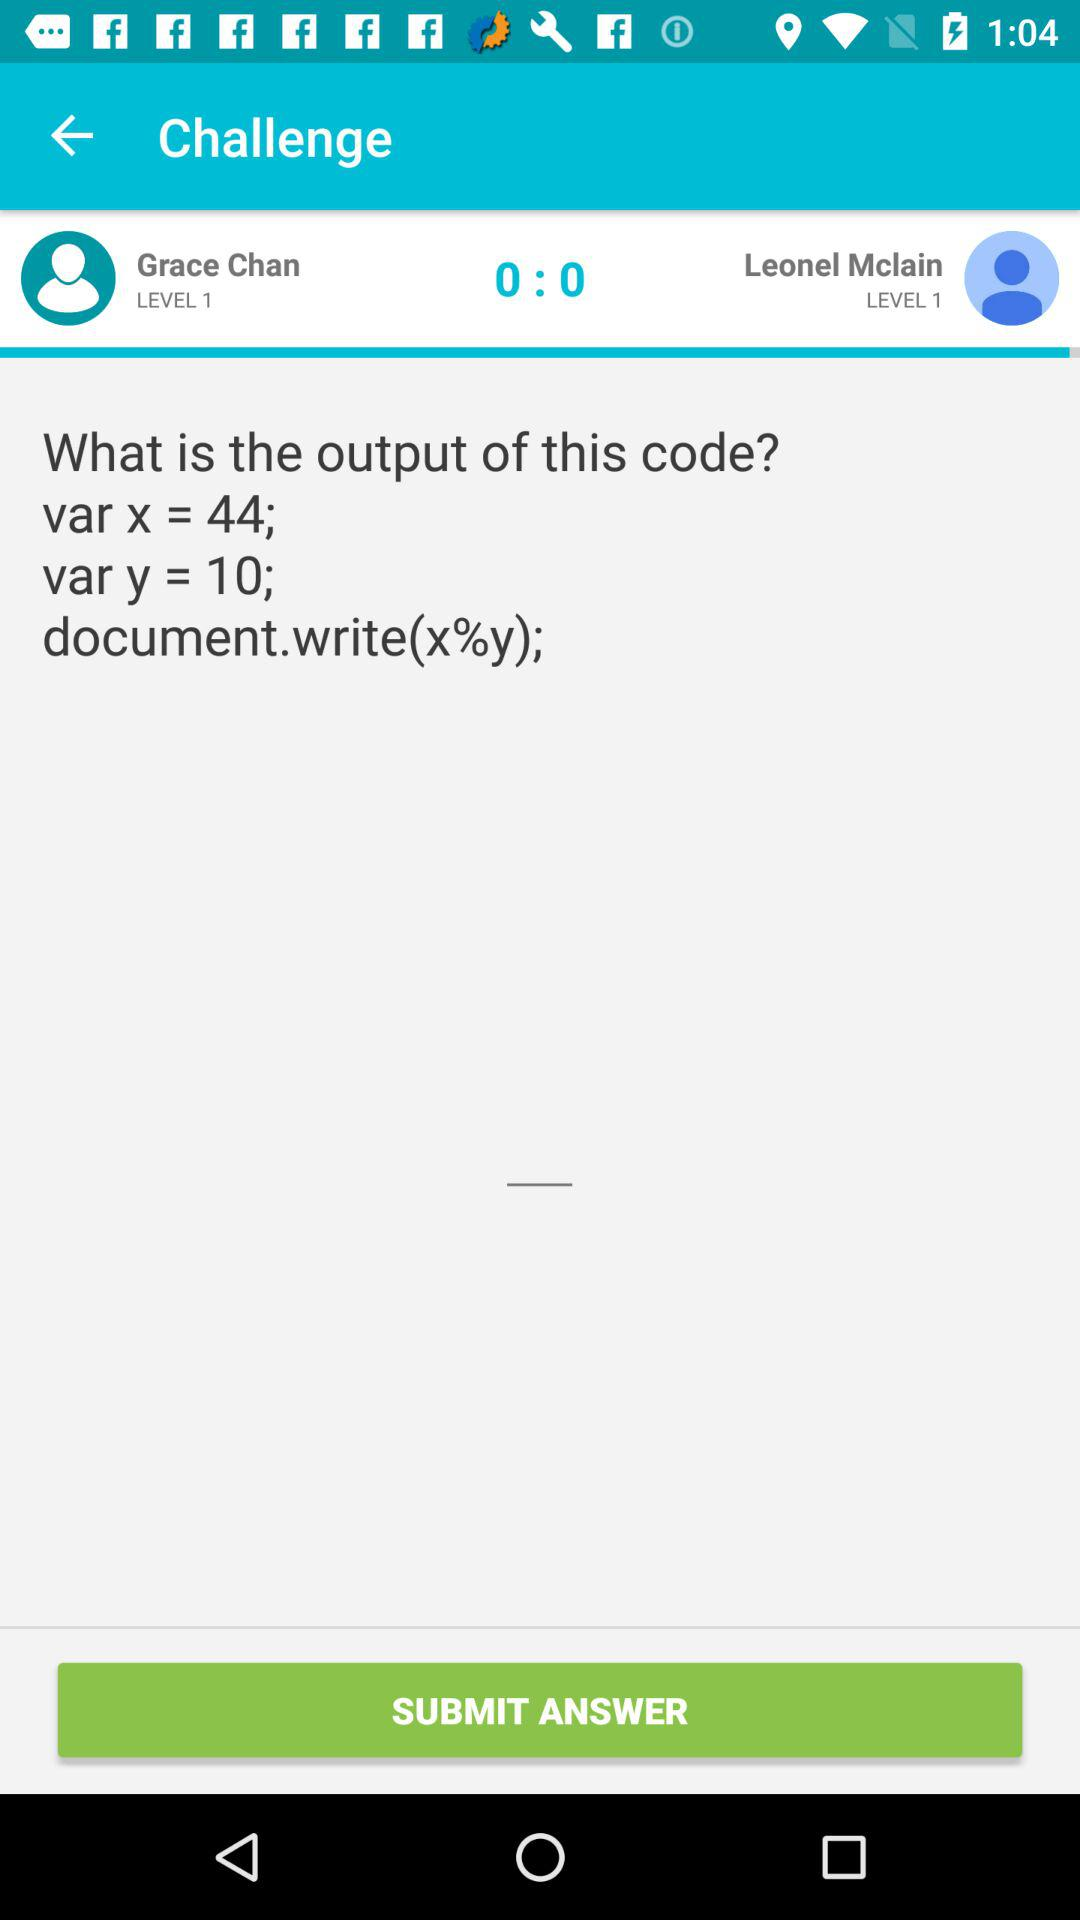What is the remainder of 44 divided by 10?
Answer the question using a single word or phrase. 4 